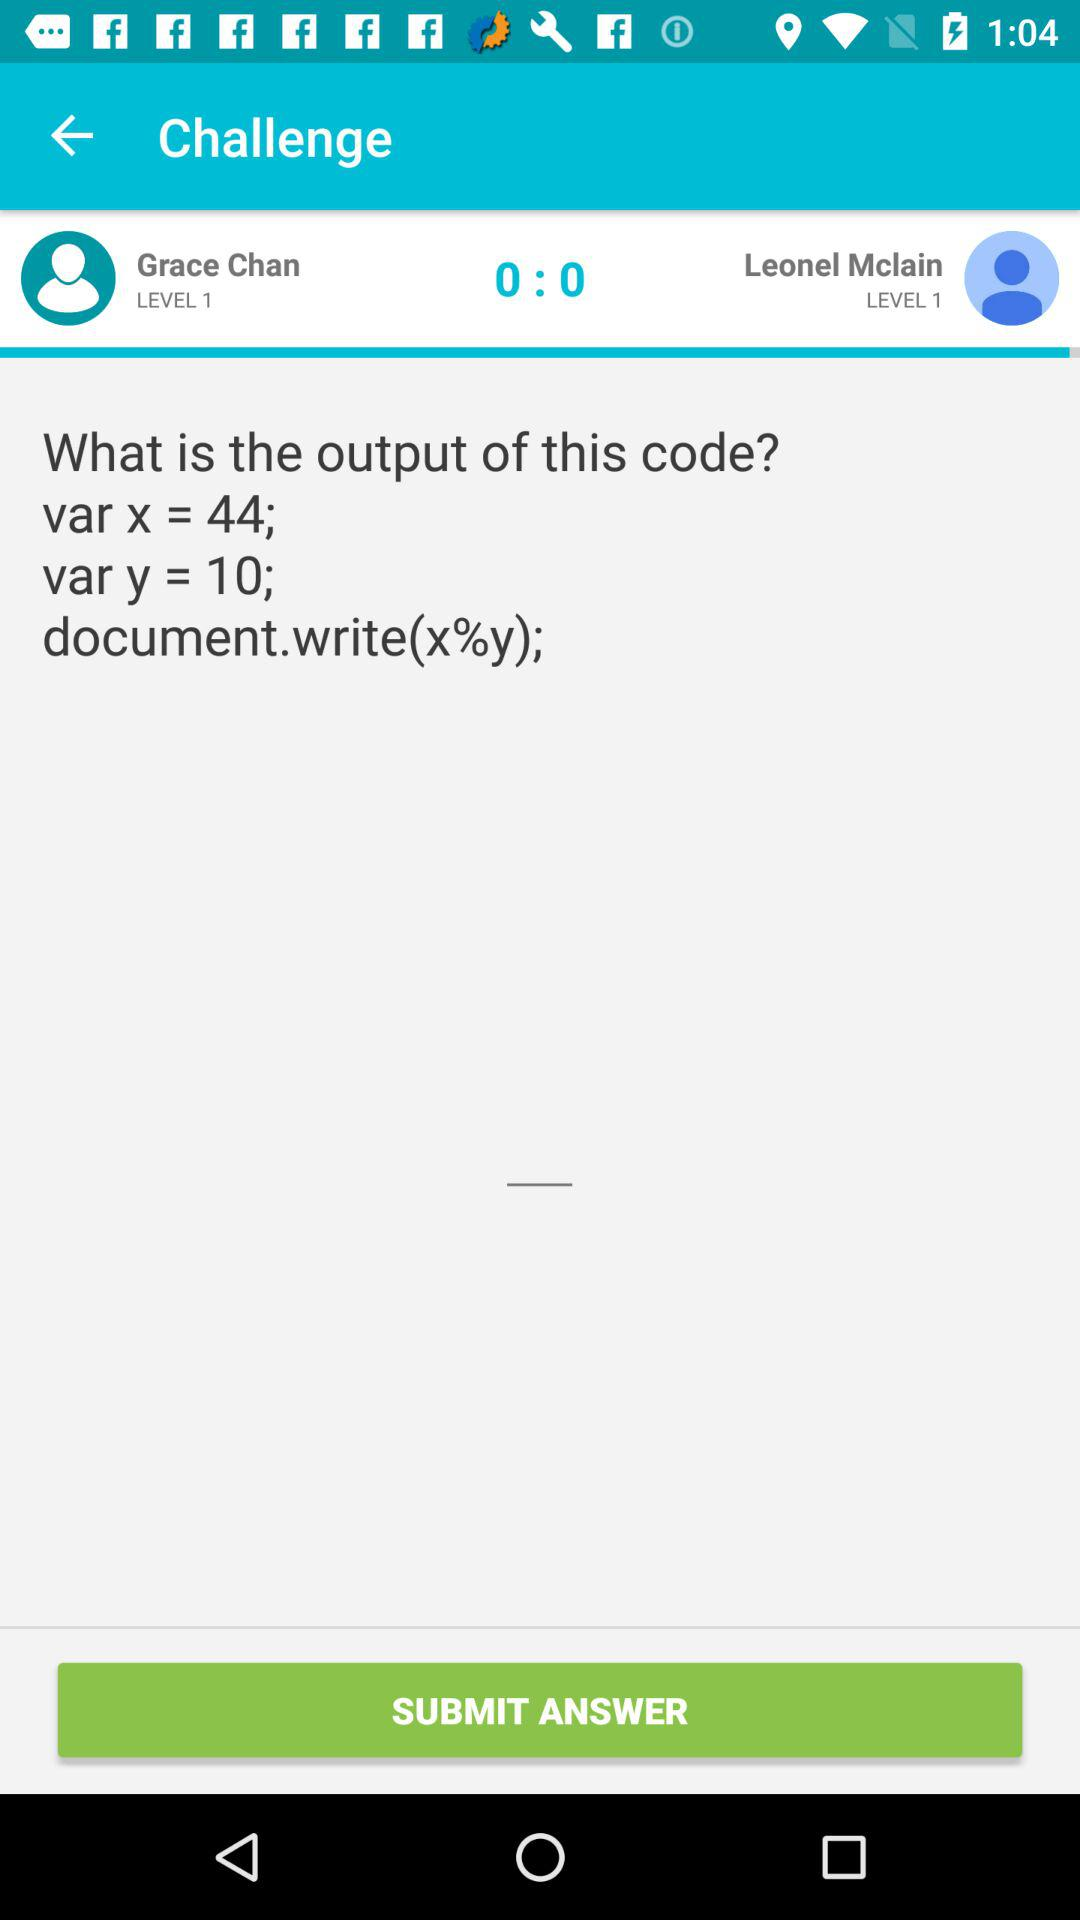What is the remainder of 44 divided by 10?
Answer the question using a single word or phrase. 4 